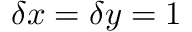<formula> <loc_0><loc_0><loc_500><loc_500>\delta x = \delta y = 1</formula> 